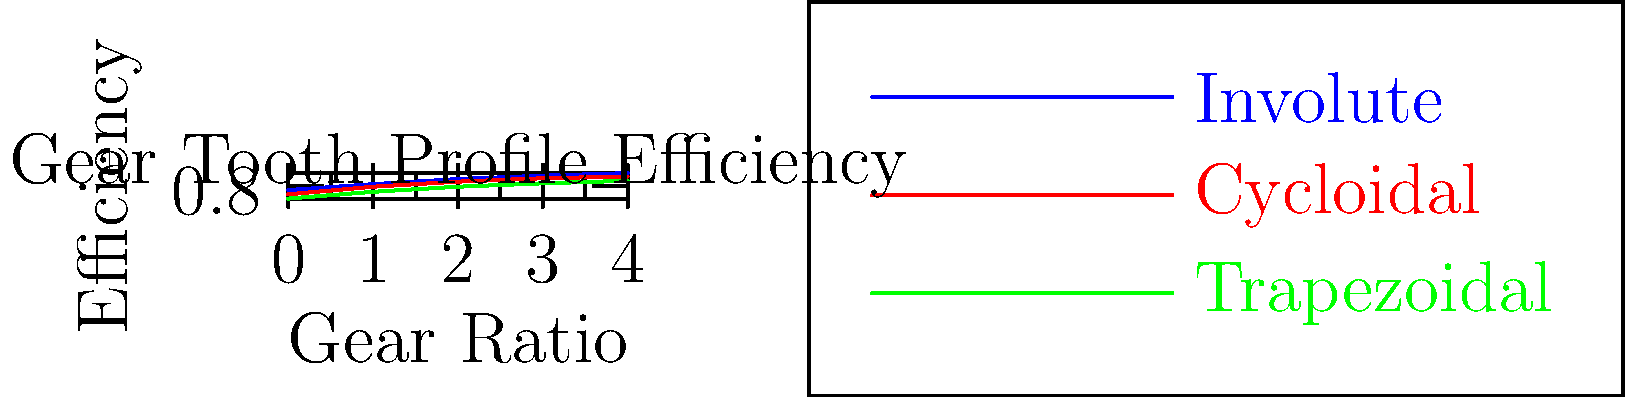As a geneticist studying neural development, you're collaborating on a project investigating the impact of mechanical stress on gene expression in neurons. Your team is designing a gear system for a precision cell culture apparatus. Based on the efficiency curves shown for different gear tooth profiles, which profile would you recommend for maximizing power transmission efficiency at higher gear ratios, and how might this choice impact your experimental design? To answer this question, we need to analyze the efficiency curves for the three gear tooth profiles:

1. Involute (blue line)
2. Cycloidal (red line)
3. Trapezoidal (green line)

Step 1: Observe the trends in efficiency as gear ratio increases.
- All profiles show increasing efficiency with higher gear ratios.
- The involute profile consistently demonstrates the highest efficiency across all gear ratios.

Step 2: Compare efficiencies at higher gear ratios (right side of the graph).
- At gear ratio 4, the approximate efficiencies are:
  Involute: 0.95
  Cycloidal: 0.91
  Trapezoidal: 0.86

Step 3: Consider the impact on experimental design.
- Higher efficiency means less power loss and heat generation.
- Reduced heat generation is crucial for maintaining precise temperature control in cell cultures.
- More efficient power transmission allows for smoother operation and potentially reduced vibration, which could minimize mechanical stress on cultured neurons.

Step 4: Make a recommendation based on the analysis.
- The involute gear tooth profile offers the highest efficiency, especially at higher gear ratios.
- This profile would be most suitable for maximizing power transmission efficiency in the cell culture apparatus.

Step 5: Consider the experimental implications.
- Using the involute profile could help maintain more stable conditions for neuron cultures.
- The improved efficiency might allow for more precise control of mechanical stimuli in gene expression studies.
- Reduced heat generation could minimize thermal stress on neurons, isolating the effects of mechanical stress in the experiment.
Answer: Involute profile; ensures optimal efficiency and stability for neuron cultures. 